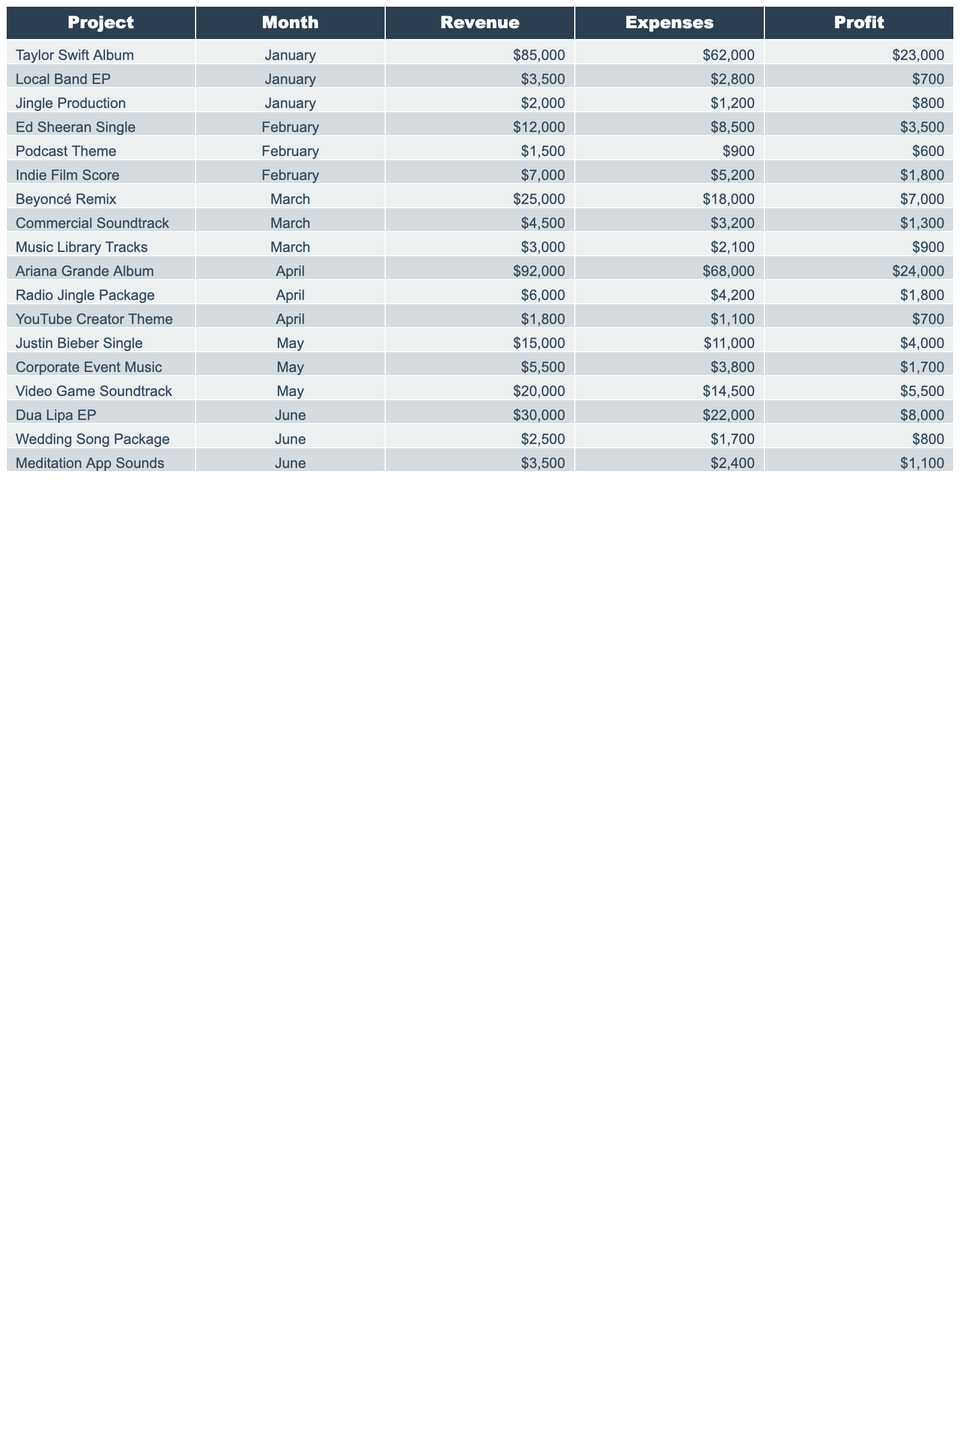What was the highest revenue project in June? In June, the project with the highest revenue is the Dua Lipa EP, which generated $30,000.
Answer: $30,000 What are the total profits from the Justin Bieber Single and Corporate Event Music combined? The profit from the Justin Bieber Single is $4,000 and from Corporate Event Music is $1,700. Adding these together gives $4,000 + $1,700 = $5,700.
Answer: $5,700 Did any project in April generate more profit than the Taylor Swift Album? The Taylor Swift Album had a profit of $23,000 in January. The Ariana Grande Album in April made a profit of $24,000, which is higher, thus confirming that it is true.
Answer: Yes Which month had the lowest total revenue across all projects? To find the month with the lowest total revenue, we can sum the revenues for each month. January: $85,000 + $3,500 + $2,000 = $90,500; February: $12,000 + $1,500 + $7,000 = $20,500; March: $25,000 + $4,500 + $3,000 = $32,500; April: $92,000 + $6,000 + $1,800 = $99,800; May: $15,000 + $5,500 + $20,000 = $40,500; June: $30,000 + $2,500 + $3,500 = $36,000. February has the lowest total revenue at $20,500.
Answer: February What was the profit margin of the Beyoncé Remix? The profit margin can be calculated using the formula: (Profit / Revenue) * 100. For the Beyoncé Remix, the profit is $7,000 and the revenue is $25,000. Thus, the profit margin is ($7,000 / $25,000) * 100 = 28%.
Answer: 28% How much more did the Ariana Grande Album earn than the Ed Sheeran Single? The Ariana Grande Album earned $92,000, while the Ed Sheeran Single earned $12,000. The difference is $92,000 - $12,000 = $80,000.
Answer: $80,000 What was the total expense for all projects in March? The total expenses in March can be added as follows: $18,000 (Beyoncé Remix) + $3,200 (Commercial Soundtrack) + $2,100 (Music Library Tracks) = $23,300.
Answer: $23,300 Is the profit from the Podcast Theme higher than the profit from the Local Band EP? The profit from the Podcast Theme is $600 while the Local Band EP has a profit of $700. Since $600 is less than $700, the answer is no.
Answer: No What is the average revenue across all projects for January? The projects in January are: Taylor Swift Album ($85,000), Local Band EP ($3,500), and Jingle Production ($2,000). Total revenue is $85,000 + $3,500 + $2,000 = $90,500. The average revenue is $90,500 / 3 = $30,166.67.
Answer: $30,166.67 How much did the Month of June contribute to the overall profit? The profits for June are: Dua Lipa EP ($8,000), Wedding Song Package ($800), and Meditation App Sounds ($1,100). Total profit for June is $8,000 + $800 + $1,100 = $9,900.
Answer: $9,900 Which project had the highest expenses in February? In February, the Indie Film Score had expenses of $5,200 which is higher than the other projects: $8,500 (Ed Sheeran Single) and $900 (Podcast Theme). Thus, the project with the highest expenses is the Ed Sheeran Single.
Answer: Ed Sheeran Single 